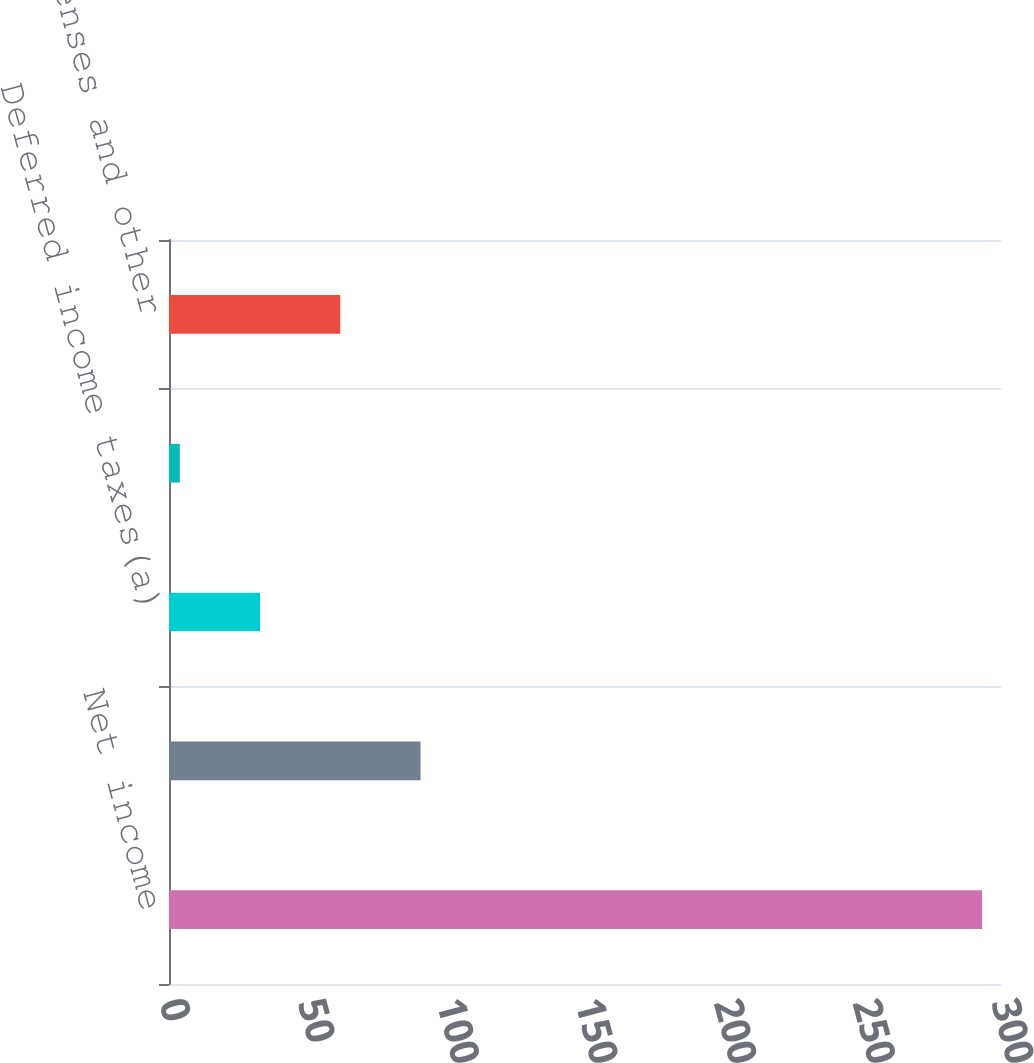<chart> <loc_0><loc_0><loc_500><loc_500><bar_chart><fcel>Net income<fcel>Depreciation and amortization<fcel>Deferred income taxes(a)<fcel>Other<fcel>Prepaid expenses and other<nl><fcel>293.2<fcel>90.69<fcel>32.83<fcel>3.9<fcel>61.76<nl></chart> 